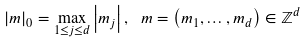Convert formula to latex. <formula><loc_0><loc_0><loc_500><loc_500>\left | m \right | _ { 0 } = \max _ { 1 \leq j \leq d } \left | m _ { j } \right | , \ m = \left ( m _ { 1 } , \dots , m _ { d } \right ) \in \mathbb { Z } ^ { d }</formula> 